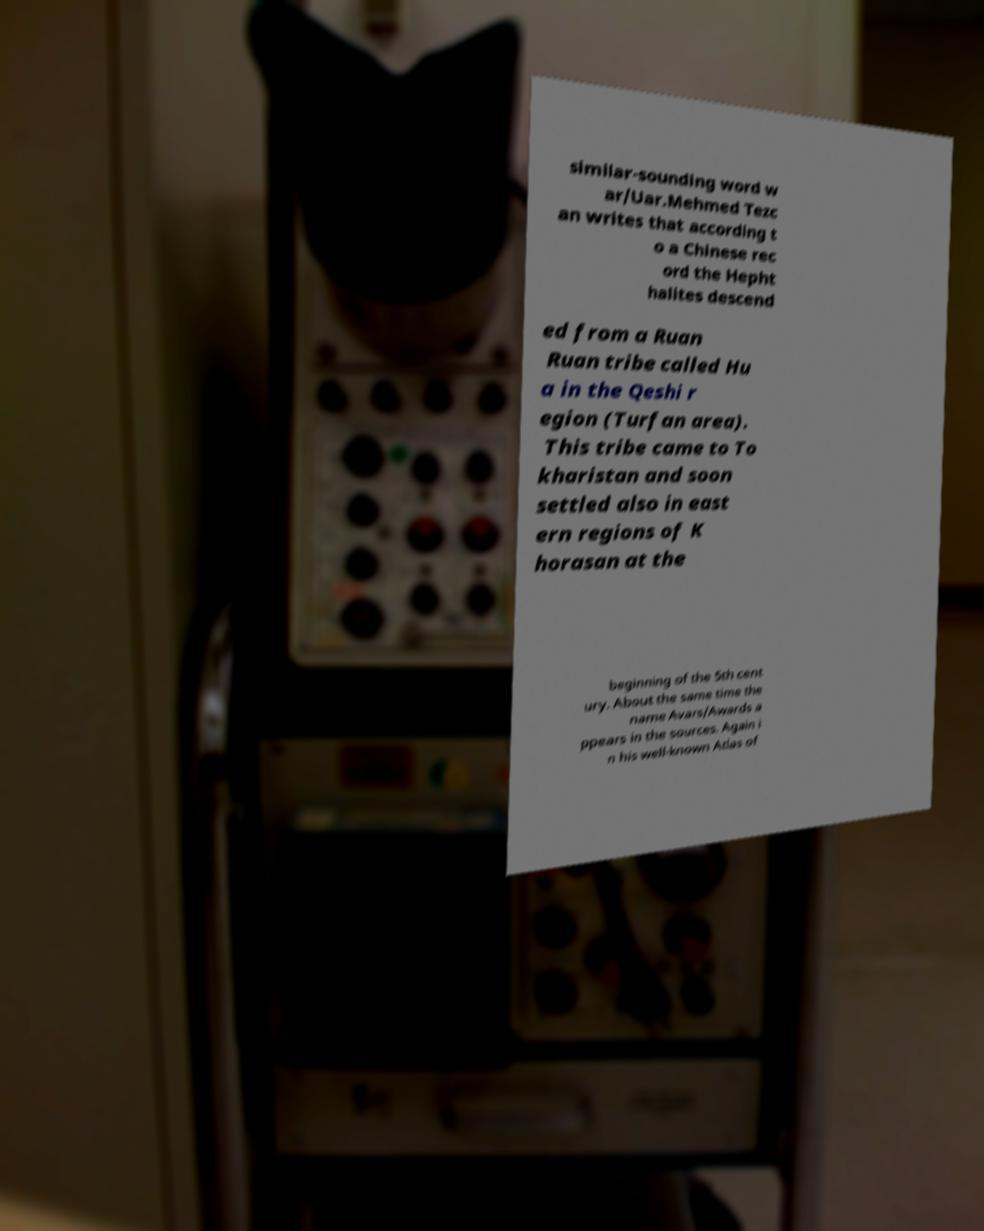Could you extract and type out the text from this image? similar-sounding word w ar/Uar.Mehmed Tezc an writes that according t o a Chinese rec ord the Hepht halites descend ed from a Ruan Ruan tribe called Hu a in the Qeshi r egion (Turfan area). This tribe came to To kharistan and soon settled also in east ern regions of K horasan at the beginning of the 5th cent ury. About the same time the name Avars/Awards a ppears in the sources. Again i n his well-known Atlas of 